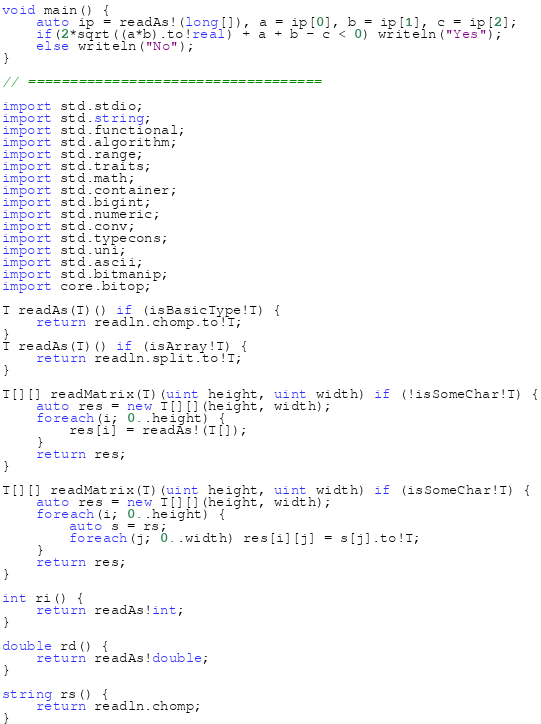Convert code to text. <code><loc_0><loc_0><loc_500><loc_500><_D_>void main() {
	auto ip = readAs!(long[]), a = ip[0], b = ip[1], c = ip[2];
	if(2*sqrt((a*b).to!real) + a + b - c < 0) writeln("Yes");
	else writeln("No");
}

// ===================================

import std.stdio;
import std.string;
import std.functional;
import std.algorithm;
import std.range;
import std.traits;
import std.math;
import std.container;
import std.bigint;
import std.numeric;
import std.conv;
import std.typecons;
import std.uni;
import std.ascii;
import std.bitmanip;
import core.bitop;

T readAs(T)() if (isBasicType!T) {
	return readln.chomp.to!T;
}
T readAs(T)() if (isArray!T) {
	return readln.split.to!T;
}

T[][] readMatrix(T)(uint height, uint width) if (!isSomeChar!T) {
	auto res = new T[][](height, width);
	foreach(i; 0..height) {
		res[i] = readAs!(T[]);
	}
	return res;
}

T[][] readMatrix(T)(uint height, uint width) if (isSomeChar!T) {
	auto res = new T[][](height, width);
	foreach(i; 0..height) {
		auto s = rs;
		foreach(j; 0..width) res[i][j] = s[j].to!T;
	}
	return res;
}

int ri() {
	return readAs!int;
}

double rd() {
	return readAs!double;
}

string rs() {
	return readln.chomp;
}</code> 